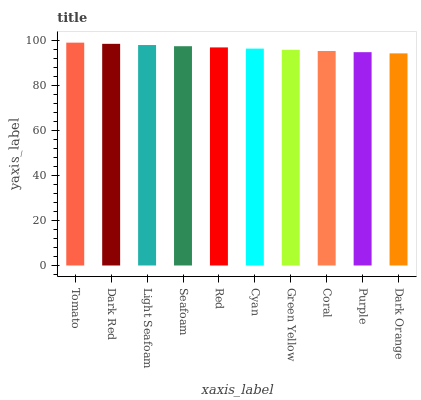Is Dark Orange the minimum?
Answer yes or no. Yes. Is Tomato the maximum?
Answer yes or no. Yes. Is Dark Red the minimum?
Answer yes or no. No. Is Dark Red the maximum?
Answer yes or no. No. Is Tomato greater than Dark Red?
Answer yes or no. Yes. Is Dark Red less than Tomato?
Answer yes or no. Yes. Is Dark Red greater than Tomato?
Answer yes or no. No. Is Tomato less than Dark Red?
Answer yes or no. No. Is Red the high median?
Answer yes or no. Yes. Is Cyan the low median?
Answer yes or no. Yes. Is Coral the high median?
Answer yes or no. No. Is Dark Orange the low median?
Answer yes or no. No. 